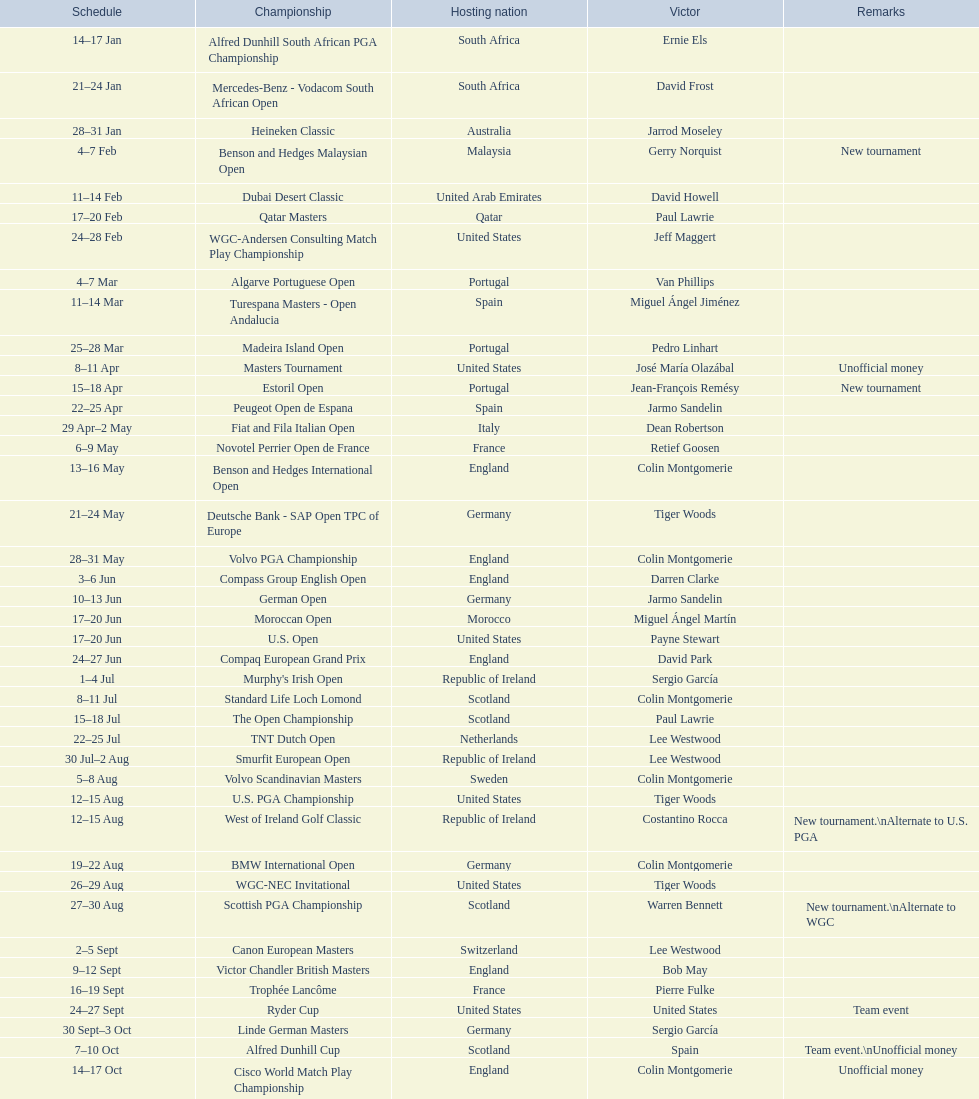How long did the estoril open last? 3 days. 